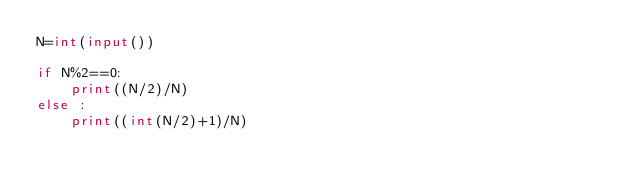Convert code to text. <code><loc_0><loc_0><loc_500><loc_500><_Python_>N=int(input())

if N%2==0:
    print((N/2)/N)
else :
    print((int(N/2)+1)/N)</code> 